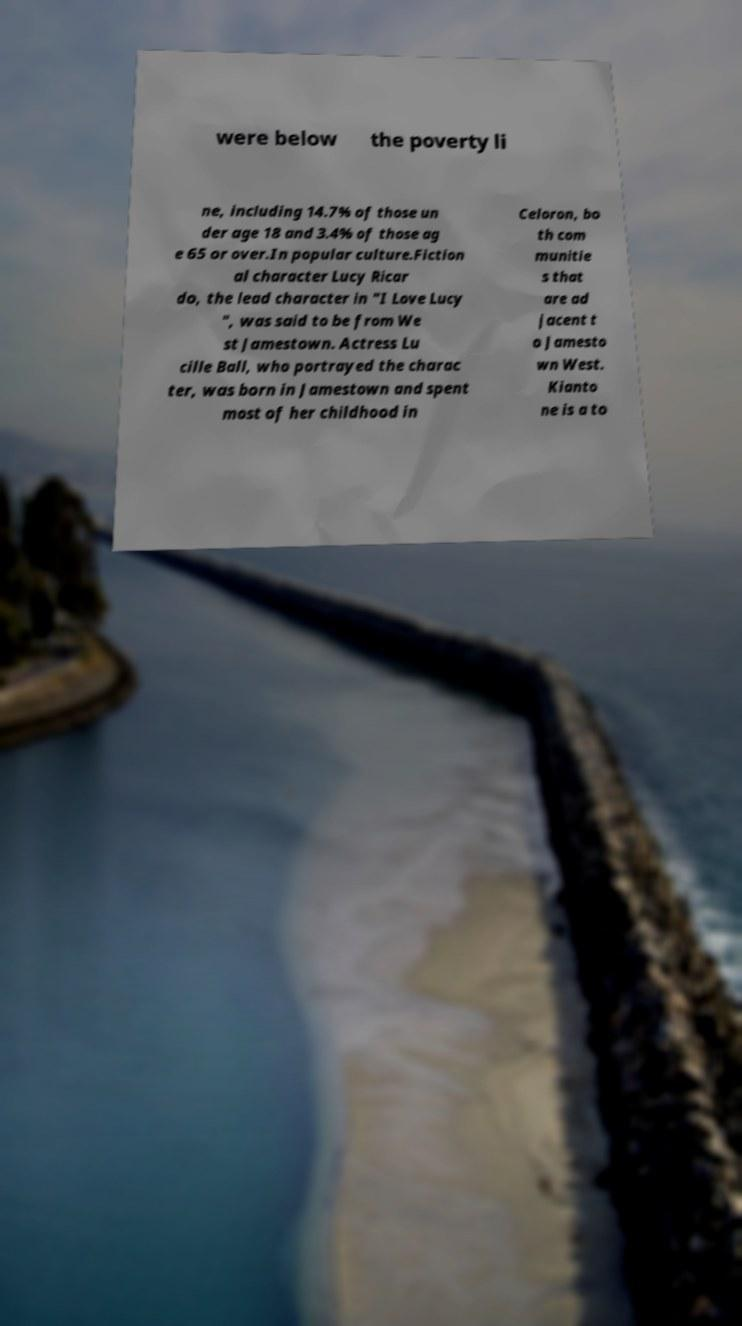Can you accurately transcribe the text from the provided image for me? were below the poverty li ne, including 14.7% of those un der age 18 and 3.4% of those ag e 65 or over.In popular culture.Fiction al character Lucy Ricar do, the lead character in "I Love Lucy ", was said to be from We st Jamestown. Actress Lu cille Ball, who portrayed the charac ter, was born in Jamestown and spent most of her childhood in Celoron, bo th com munitie s that are ad jacent t o Jamesto wn West. Kianto ne is a to 